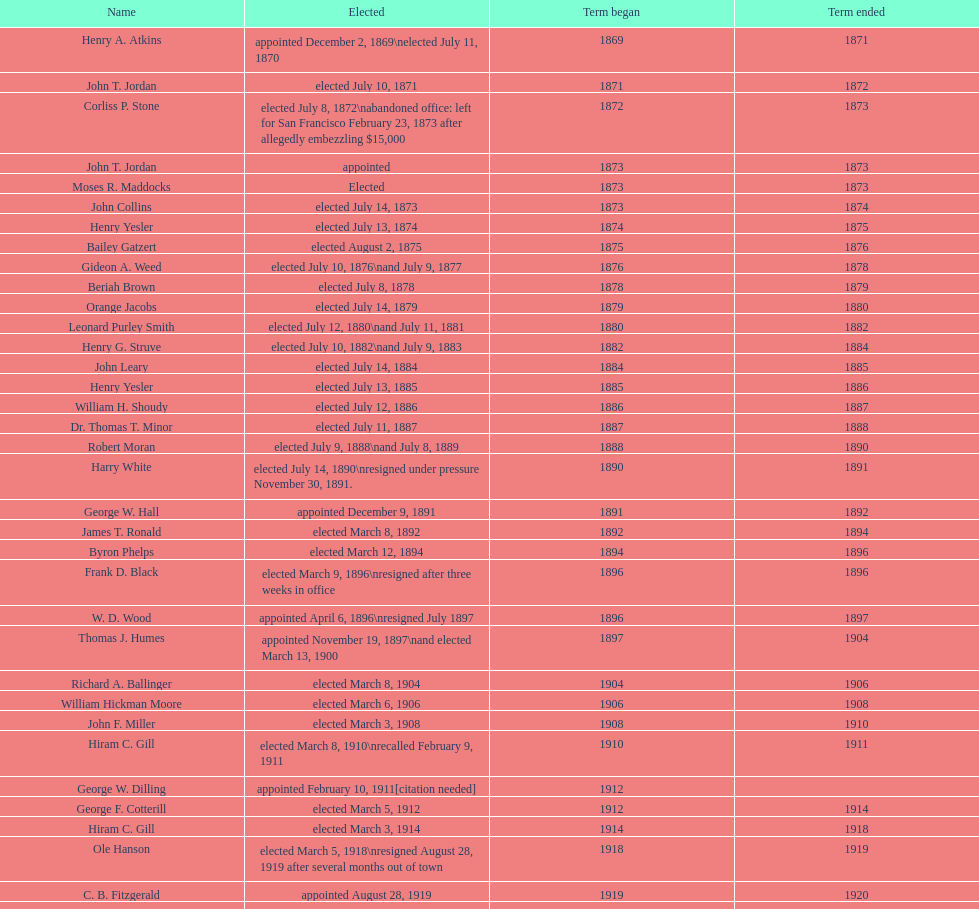In seattle, washington, how many times has a woman been elected as mayor? 1. 